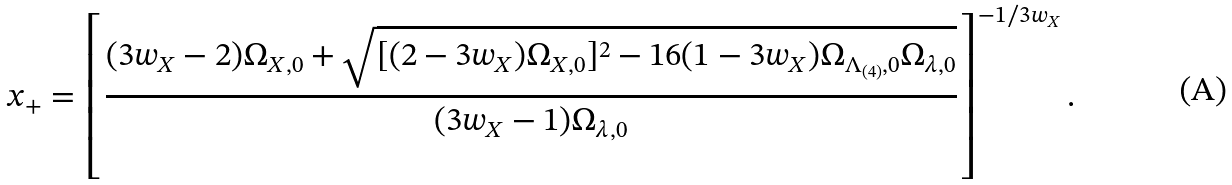Convert formula to latex. <formula><loc_0><loc_0><loc_500><loc_500>x _ { + } = \left [ \frac { ( 3 w _ { X } - 2 ) \Omega _ { X , 0 } + \sqrt { [ ( 2 - 3 w _ { X } ) \Omega _ { X , 0 } ] ^ { 2 } - 1 6 ( 1 - 3 w _ { X } ) \Omega _ { \Lambda _ { ( 4 ) } , 0 } \Omega _ { \lambda , 0 } } } { ( 3 w _ { X } - 1 ) \Omega _ { \lambda , 0 } } \right ] ^ { - 1 / 3 w _ { X } } .</formula> 